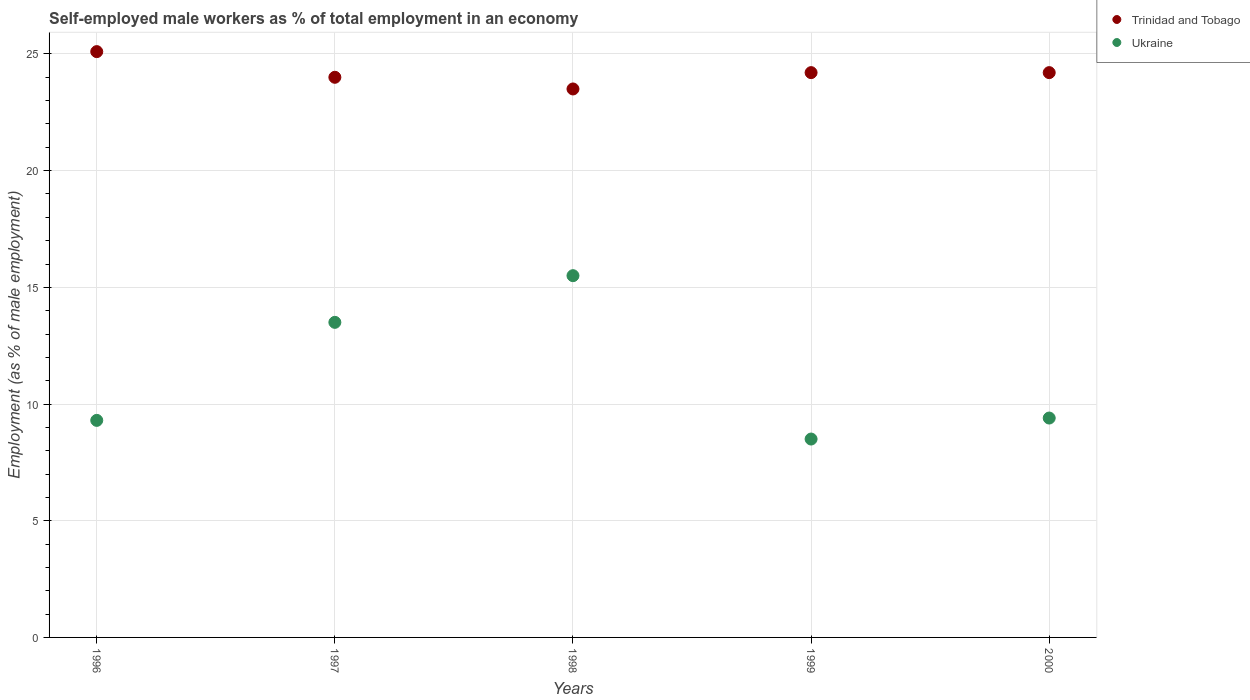What is the percentage of self-employed male workers in Ukraine in 2000?
Your answer should be very brief. 9.4. Across all years, what is the maximum percentage of self-employed male workers in Trinidad and Tobago?
Provide a succinct answer. 25.1. Across all years, what is the minimum percentage of self-employed male workers in Ukraine?
Keep it short and to the point. 8.5. In which year was the percentage of self-employed male workers in Ukraine maximum?
Offer a terse response. 1998. In which year was the percentage of self-employed male workers in Ukraine minimum?
Your answer should be very brief. 1999. What is the total percentage of self-employed male workers in Trinidad and Tobago in the graph?
Provide a succinct answer. 121. What is the difference between the percentage of self-employed male workers in Ukraine in 1997 and that in 2000?
Provide a short and direct response. 4.1. What is the difference between the percentage of self-employed male workers in Ukraine in 1997 and the percentage of self-employed male workers in Trinidad and Tobago in 1999?
Give a very brief answer. -10.7. What is the average percentage of self-employed male workers in Ukraine per year?
Offer a very short reply. 11.24. In how many years, is the percentage of self-employed male workers in Ukraine greater than 22 %?
Provide a short and direct response. 0. What is the ratio of the percentage of self-employed male workers in Ukraine in 1996 to that in 1997?
Provide a succinct answer. 0.69. Is the percentage of self-employed male workers in Trinidad and Tobago in 1998 less than that in 2000?
Offer a terse response. Yes. What is the difference between the highest and the lowest percentage of self-employed male workers in Trinidad and Tobago?
Provide a succinct answer. 1.6. Is the sum of the percentage of self-employed male workers in Ukraine in 1998 and 1999 greater than the maximum percentage of self-employed male workers in Trinidad and Tobago across all years?
Give a very brief answer. No. Does the percentage of self-employed male workers in Ukraine monotonically increase over the years?
Offer a very short reply. No. How many dotlines are there?
Provide a succinct answer. 2. How many years are there in the graph?
Keep it short and to the point. 5. Are the values on the major ticks of Y-axis written in scientific E-notation?
Your answer should be very brief. No. How are the legend labels stacked?
Your answer should be compact. Vertical. What is the title of the graph?
Give a very brief answer. Self-employed male workers as % of total employment in an economy. What is the label or title of the Y-axis?
Provide a short and direct response. Employment (as % of male employment). What is the Employment (as % of male employment) in Trinidad and Tobago in 1996?
Provide a succinct answer. 25.1. What is the Employment (as % of male employment) in Ukraine in 1996?
Offer a very short reply. 9.3. What is the Employment (as % of male employment) of Ukraine in 1998?
Your answer should be compact. 15.5. What is the Employment (as % of male employment) of Trinidad and Tobago in 1999?
Give a very brief answer. 24.2. What is the Employment (as % of male employment) in Trinidad and Tobago in 2000?
Give a very brief answer. 24.2. What is the Employment (as % of male employment) of Ukraine in 2000?
Offer a terse response. 9.4. Across all years, what is the maximum Employment (as % of male employment) in Trinidad and Tobago?
Make the answer very short. 25.1. Across all years, what is the maximum Employment (as % of male employment) of Ukraine?
Offer a very short reply. 15.5. Across all years, what is the minimum Employment (as % of male employment) of Trinidad and Tobago?
Make the answer very short. 23.5. What is the total Employment (as % of male employment) of Trinidad and Tobago in the graph?
Provide a short and direct response. 121. What is the total Employment (as % of male employment) of Ukraine in the graph?
Your answer should be compact. 56.2. What is the difference between the Employment (as % of male employment) of Ukraine in 1996 and that in 1997?
Ensure brevity in your answer.  -4.2. What is the difference between the Employment (as % of male employment) in Trinidad and Tobago in 1996 and that in 1998?
Your response must be concise. 1.6. What is the difference between the Employment (as % of male employment) of Trinidad and Tobago in 1996 and that in 1999?
Offer a terse response. 0.9. What is the difference between the Employment (as % of male employment) of Trinidad and Tobago in 1996 and that in 2000?
Provide a succinct answer. 0.9. What is the difference between the Employment (as % of male employment) in Ukraine in 1996 and that in 2000?
Make the answer very short. -0.1. What is the difference between the Employment (as % of male employment) in Trinidad and Tobago in 1997 and that in 1998?
Offer a very short reply. 0.5. What is the difference between the Employment (as % of male employment) of Trinidad and Tobago in 1997 and that in 1999?
Ensure brevity in your answer.  -0.2. What is the difference between the Employment (as % of male employment) of Ukraine in 1998 and that in 1999?
Offer a terse response. 7. What is the difference between the Employment (as % of male employment) in Trinidad and Tobago in 1998 and that in 2000?
Keep it short and to the point. -0.7. What is the difference between the Employment (as % of male employment) in Ukraine in 1998 and that in 2000?
Ensure brevity in your answer.  6.1. What is the difference between the Employment (as % of male employment) in Trinidad and Tobago in 1999 and that in 2000?
Offer a terse response. 0. What is the difference between the Employment (as % of male employment) in Trinidad and Tobago in 1996 and the Employment (as % of male employment) in Ukraine in 1997?
Offer a very short reply. 11.6. What is the difference between the Employment (as % of male employment) of Trinidad and Tobago in 1996 and the Employment (as % of male employment) of Ukraine in 1998?
Your answer should be compact. 9.6. What is the difference between the Employment (as % of male employment) of Trinidad and Tobago in 1996 and the Employment (as % of male employment) of Ukraine in 1999?
Ensure brevity in your answer.  16.6. What is the difference between the Employment (as % of male employment) in Trinidad and Tobago in 1996 and the Employment (as % of male employment) in Ukraine in 2000?
Give a very brief answer. 15.7. What is the difference between the Employment (as % of male employment) of Trinidad and Tobago in 1997 and the Employment (as % of male employment) of Ukraine in 1998?
Offer a very short reply. 8.5. What is the difference between the Employment (as % of male employment) in Trinidad and Tobago in 1997 and the Employment (as % of male employment) in Ukraine in 1999?
Give a very brief answer. 15.5. What is the difference between the Employment (as % of male employment) of Trinidad and Tobago in 1997 and the Employment (as % of male employment) of Ukraine in 2000?
Give a very brief answer. 14.6. What is the difference between the Employment (as % of male employment) in Trinidad and Tobago in 1998 and the Employment (as % of male employment) in Ukraine in 2000?
Offer a terse response. 14.1. What is the difference between the Employment (as % of male employment) of Trinidad and Tobago in 1999 and the Employment (as % of male employment) of Ukraine in 2000?
Offer a terse response. 14.8. What is the average Employment (as % of male employment) in Trinidad and Tobago per year?
Offer a very short reply. 24.2. What is the average Employment (as % of male employment) in Ukraine per year?
Ensure brevity in your answer.  11.24. In the year 1996, what is the difference between the Employment (as % of male employment) of Trinidad and Tobago and Employment (as % of male employment) of Ukraine?
Provide a short and direct response. 15.8. In the year 2000, what is the difference between the Employment (as % of male employment) of Trinidad and Tobago and Employment (as % of male employment) of Ukraine?
Give a very brief answer. 14.8. What is the ratio of the Employment (as % of male employment) in Trinidad and Tobago in 1996 to that in 1997?
Offer a terse response. 1.05. What is the ratio of the Employment (as % of male employment) of Ukraine in 1996 to that in 1997?
Give a very brief answer. 0.69. What is the ratio of the Employment (as % of male employment) of Trinidad and Tobago in 1996 to that in 1998?
Provide a succinct answer. 1.07. What is the ratio of the Employment (as % of male employment) in Ukraine in 1996 to that in 1998?
Your answer should be very brief. 0.6. What is the ratio of the Employment (as % of male employment) of Trinidad and Tobago in 1996 to that in 1999?
Your response must be concise. 1.04. What is the ratio of the Employment (as % of male employment) in Ukraine in 1996 to that in 1999?
Offer a terse response. 1.09. What is the ratio of the Employment (as % of male employment) of Trinidad and Tobago in 1996 to that in 2000?
Offer a very short reply. 1.04. What is the ratio of the Employment (as % of male employment) in Trinidad and Tobago in 1997 to that in 1998?
Your response must be concise. 1.02. What is the ratio of the Employment (as % of male employment) in Ukraine in 1997 to that in 1998?
Keep it short and to the point. 0.87. What is the ratio of the Employment (as % of male employment) in Ukraine in 1997 to that in 1999?
Ensure brevity in your answer.  1.59. What is the ratio of the Employment (as % of male employment) in Trinidad and Tobago in 1997 to that in 2000?
Your response must be concise. 0.99. What is the ratio of the Employment (as % of male employment) in Ukraine in 1997 to that in 2000?
Provide a succinct answer. 1.44. What is the ratio of the Employment (as % of male employment) in Trinidad and Tobago in 1998 to that in 1999?
Offer a terse response. 0.97. What is the ratio of the Employment (as % of male employment) of Ukraine in 1998 to that in 1999?
Ensure brevity in your answer.  1.82. What is the ratio of the Employment (as % of male employment) of Trinidad and Tobago in 1998 to that in 2000?
Offer a terse response. 0.97. What is the ratio of the Employment (as % of male employment) of Ukraine in 1998 to that in 2000?
Give a very brief answer. 1.65. What is the ratio of the Employment (as % of male employment) of Trinidad and Tobago in 1999 to that in 2000?
Your answer should be very brief. 1. What is the ratio of the Employment (as % of male employment) in Ukraine in 1999 to that in 2000?
Ensure brevity in your answer.  0.9. What is the difference between the highest and the lowest Employment (as % of male employment) in Trinidad and Tobago?
Give a very brief answer. 1.6. 